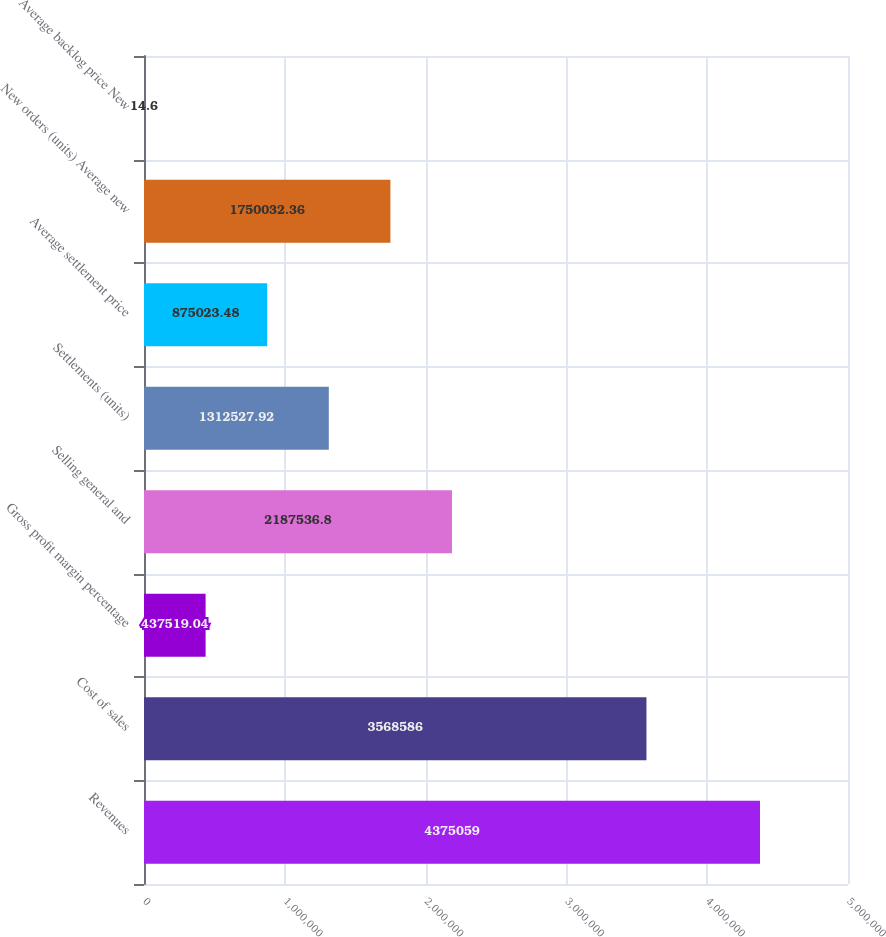Convert chart to OTSL. <chart><loc_0><loc_0><loc_500><loc_500><bar_chart><fcel>Revenues<fcel>Cost of sales<fcel>Gross profit margin percentage<fcel>Selling general and<fcel>Settlements (units)<fcel>Average settlement price<fcel>New orders (units) Average new<fcel>Average backlog price New<nl><fcel>4.37506e+06<fcel>3.56859e+06<fcel>437519<fcel>2.18754e+06<fcel>1.31253e+06<fcel>875023<fcel>1.75003e+06<fcel>14.6<nl></chart> 